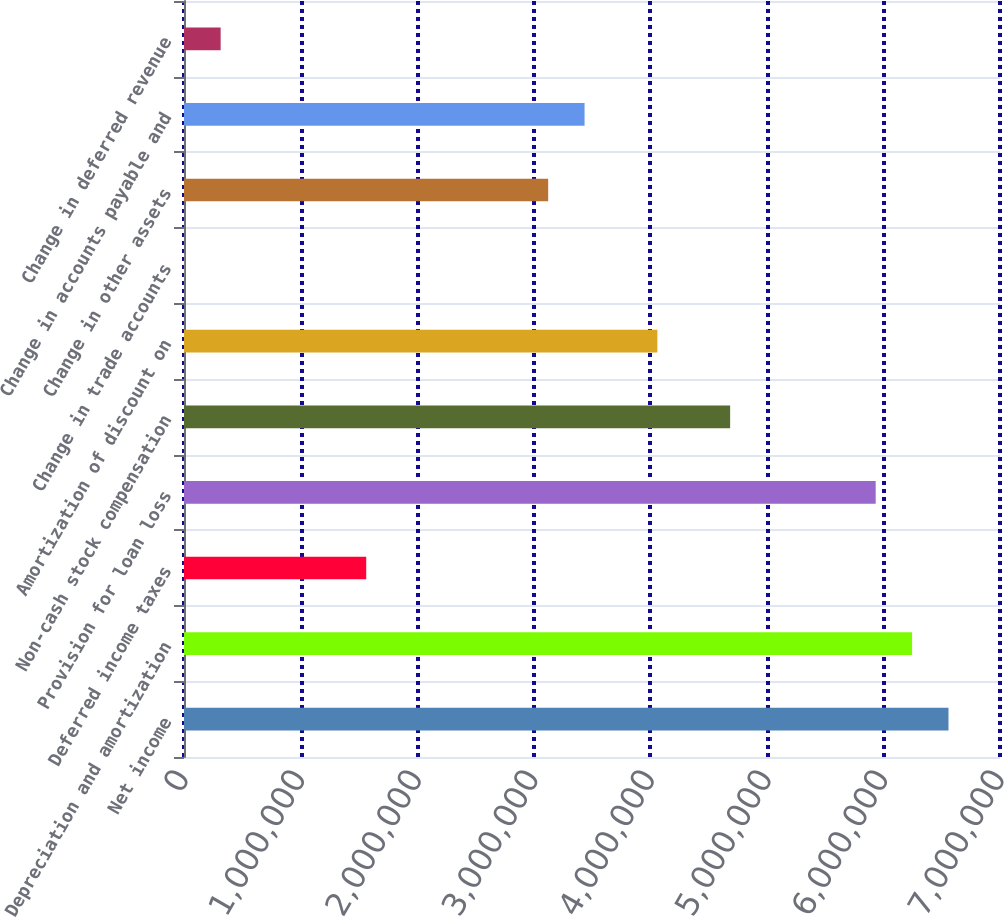<chart> <loc_0><loc_0><loc_500><loc_500><bar_chart><fcel>Net income<fcel>Depreciation and amortization<fcel>Deferred income taxes<fcel>Provision for loan loss<fcel>Non-cash stock compensation<fcel>Amortization of discount on<fcel>Change in trade accounts<fcel>Change in other assets<fcel>Change in accounts payable and<fcel>Change in deferred revenue<nl><fcel>6.55802e+06<fcel>6.24584e+06<fcel>1.56308e+06<fcel>5.93365e+06<fcel>4.68492e+06<fcel>4.06055e+06<fcel>2162<fcel>3.124e+06<fcel>3.43618e+06<fcel>314346<nl></chart> 